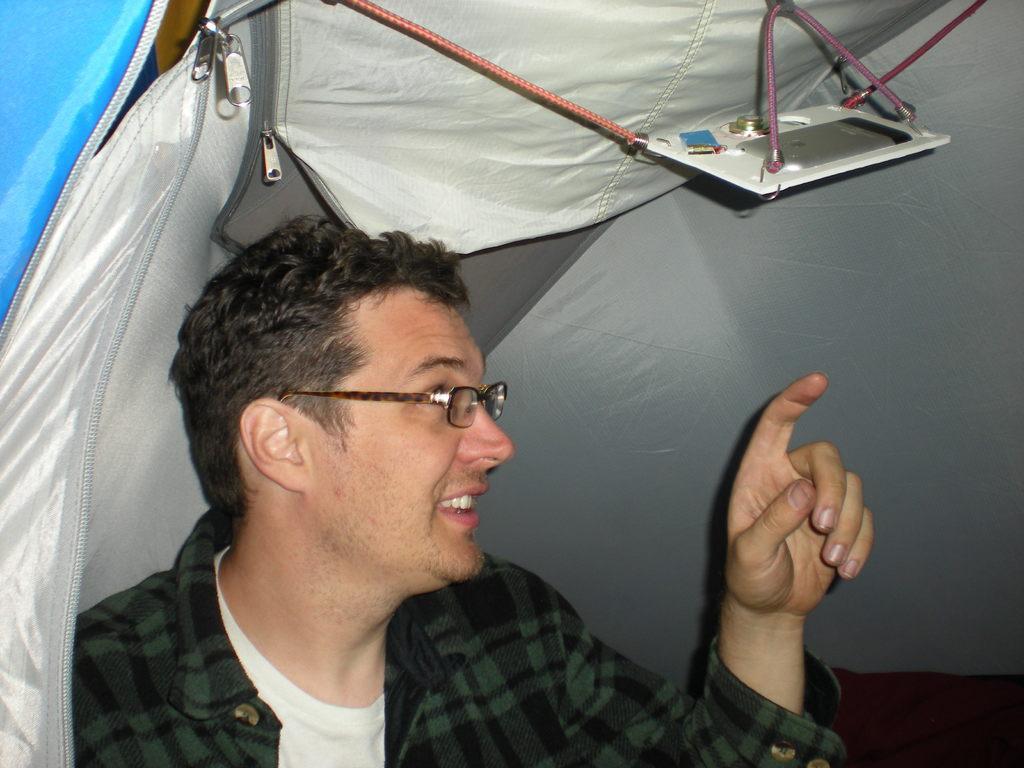Please provide a concise description of this image. At the bottom of this image, there is a person in a white color shirt, wearing a spectacle, showing something and smiling. Above him, there is an object attached to a thread, which is connected to the sheet of a tent. 